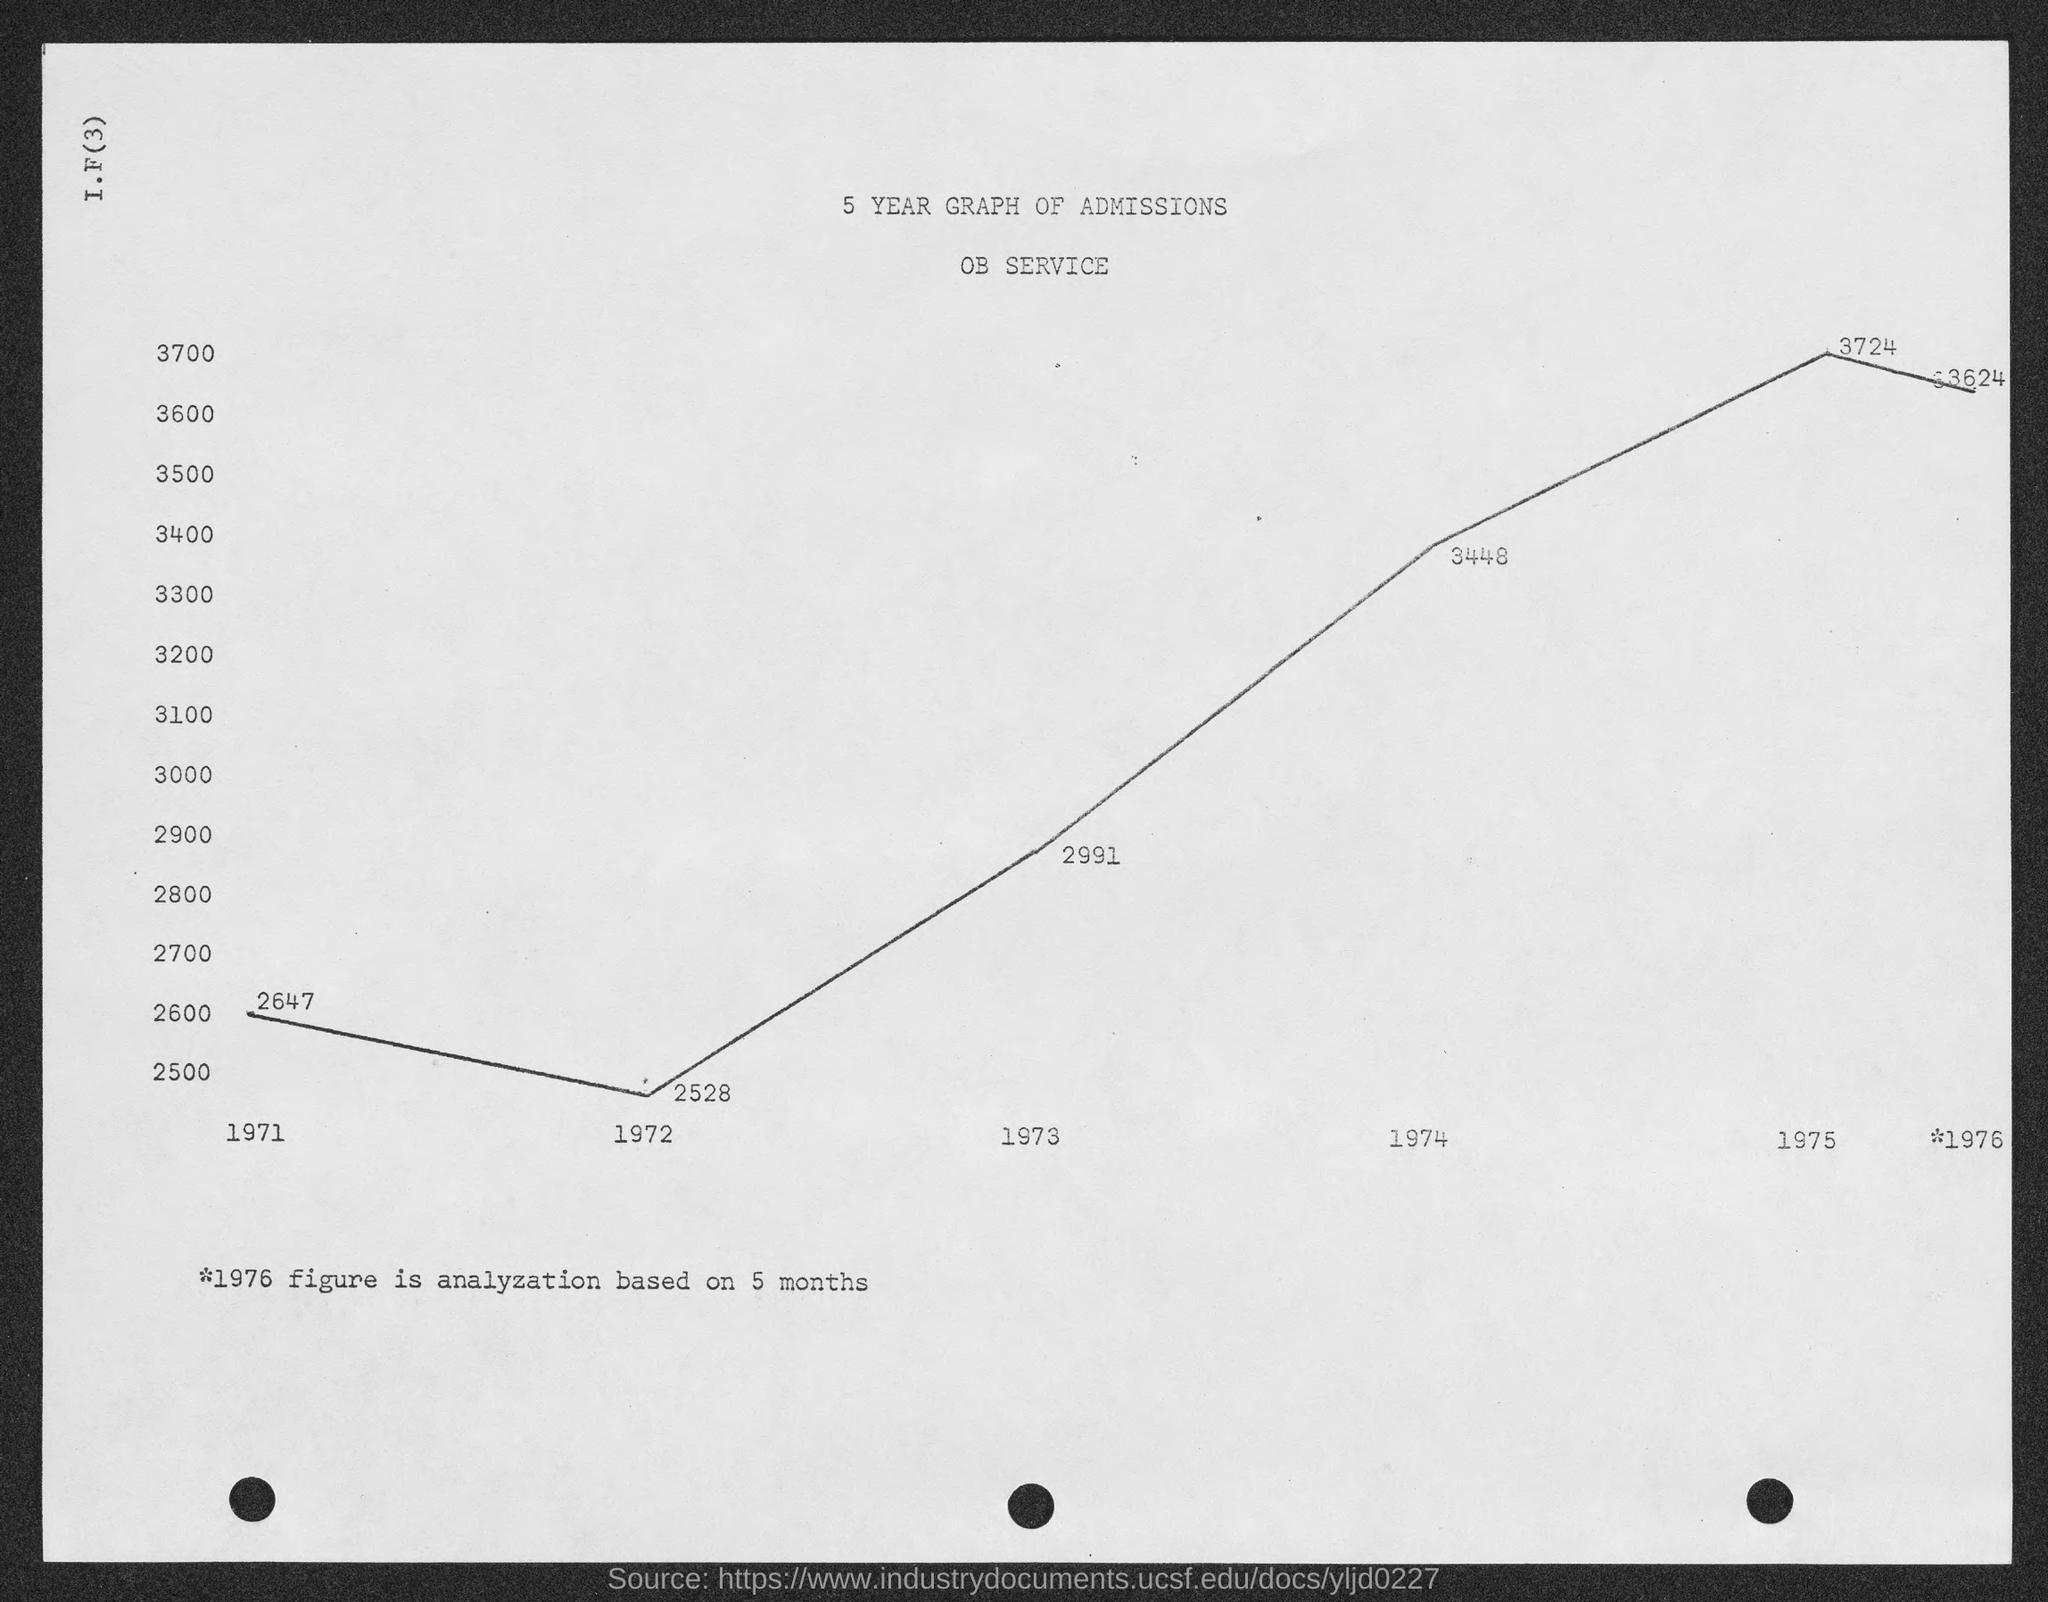What are the number of admissions in the year 1971 as shown in the graph ?
Provide a succinct answer. 2647. What are the number of admissions in the year 1972 as shown in the graph ?
Keep it short and to the point. 2528. What are the number of admissions in the year 1973 as shown in the graph ?
Ensure brevity in your answer.  2991. What are the number of admissions in the year 1974 as shown in the graph ?
Give a very brief answer. 3448. What are the number of admissions in the year 1975 as shown in the graph ?
Provide a short and direct response. 3724. 